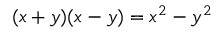Convert formula to latex. <formula><loc_0><loc_0><loc_500><loc_500>( x + y ) ( x - y ) = x ^ { 2 } - y ^ { 2 }</formula> 